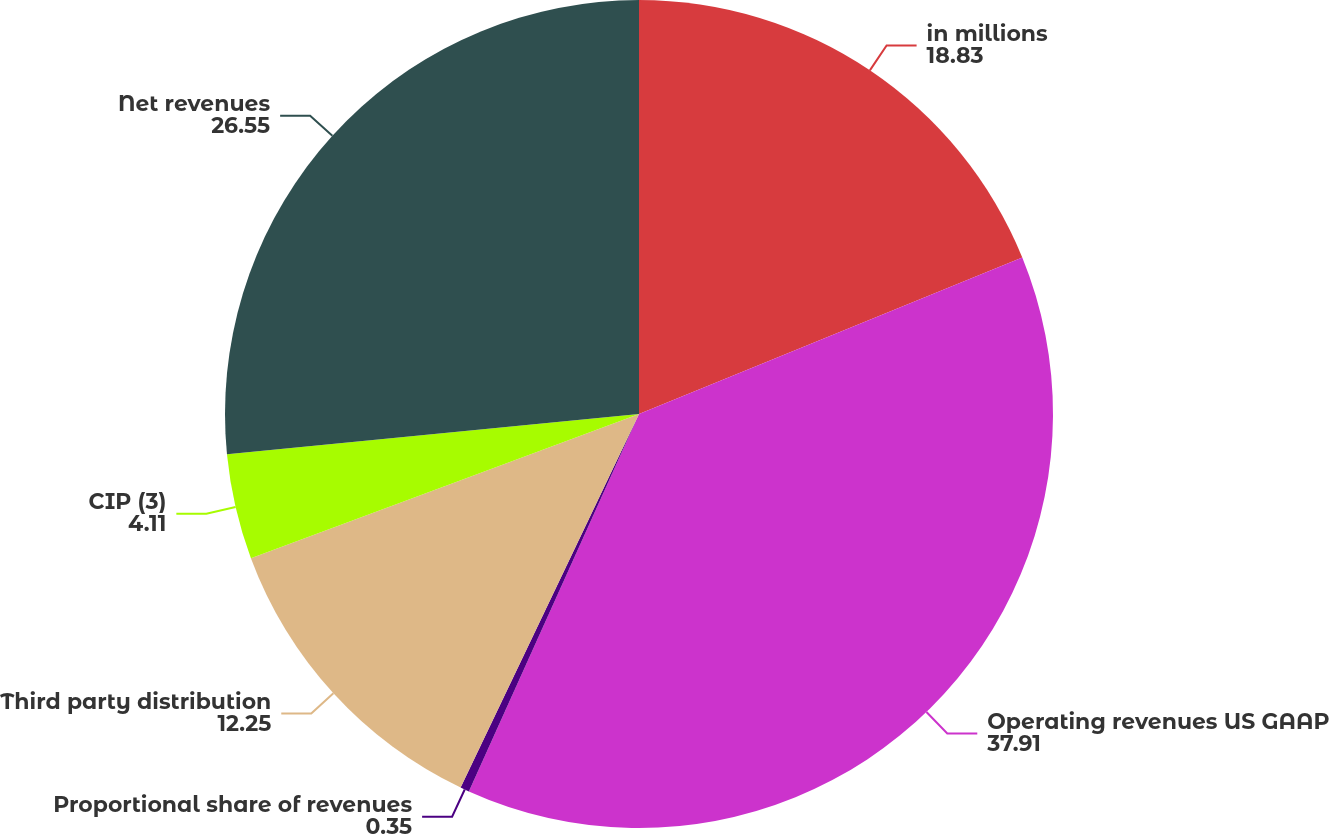Convert chart to OTSL. <chart><loc_0><loc_0><loc_500><loc_500><pie_chart><fcel>in millions<fcel>Operating revenues US GAAP<fcel>Proportional share of revenues<fcel>Third party distribution<fcel>CIP (3)<fcel>Net revenues<nl><fcel>18.83%<fcel>37.91%<fcel>0.35%<fcel>12.25%<fcel>4.11%<fcel>26.55%<nl></chart> 